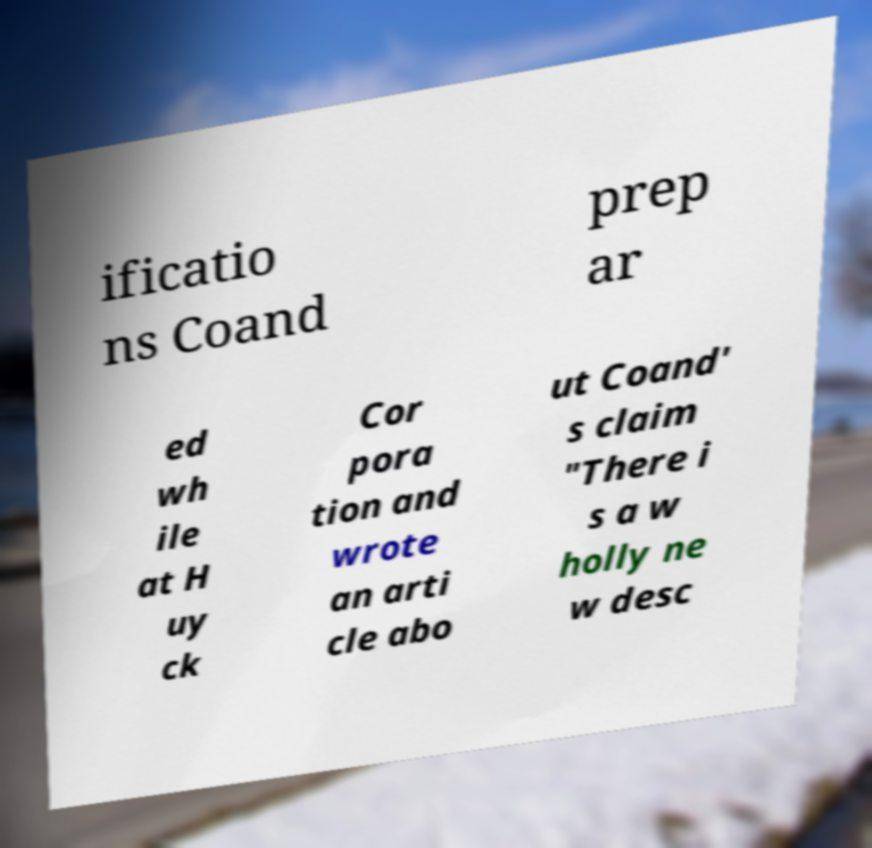Can you read and provide the text displayed in the image?This photo seems to have some interesting text. Can you extract and type it out for me? ificatio ns Coand prep ar ed wh ile at H uy ck Cor pora tion and wrote an arti cle abo ut Coand' s claim "There i s a w holly ne w desc 